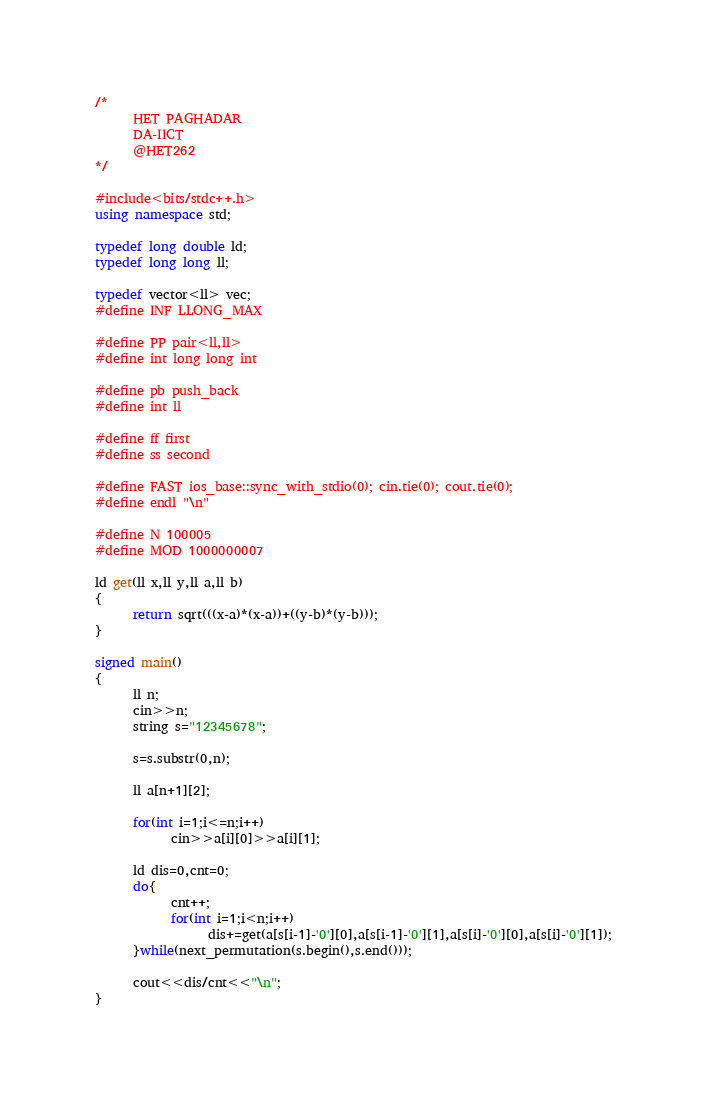Convert code to text. <code><loc_0><loc_0><loc_500><loc_500><_C++_>/*
      HET PAGHADAR
      DA-IICT
      @HET262
*/
 
#include<bits/stdc++.h>
using namespace std;
 
typedef long double ld;
typedef long long ll;
 
typedef vector<ll> vec;
#define INF LLONG_MAX
 
#define PP pair<ll,ll>
#define int long long int
 
#define pb push_back
#define int ll
 
#define ff first
#define ss second
 
#define FAST ios_base::sync_with_stdio(0); cin.tie(0); cout.tie(0);
#define endl "\n"
 
#define N 100005
#define MOD 1000000007

ld get(ll x,ll y,ll a,ll b)
{
      return sqrt(((x-a)*(x-a))+((y-b)*(y-b)));
}
      
signed main()
{
      ll n;
      cin>>n;
      string s="12345678";
      
      s=s.substr(0,n);
      
      ll a[n+1][2];
      
      for(int i=1;i<=n;i++)
            cin>>a[i][0]>>a[i][1];
      
      ld dis=0,cnt=0;
      do{
            cnt++;
            for(int i=1;i<n;i++)
                  dis+=get(a[s[i-1]-'0'][0],a[s[i-1]-'0'][1],a[s[i]-'0'][0],a[s[i]-'0'][1]);
      }while(next_permutation(s.begin(),s.end()));
      
      cout<<dis/cnt<<"\n";
}</code> 